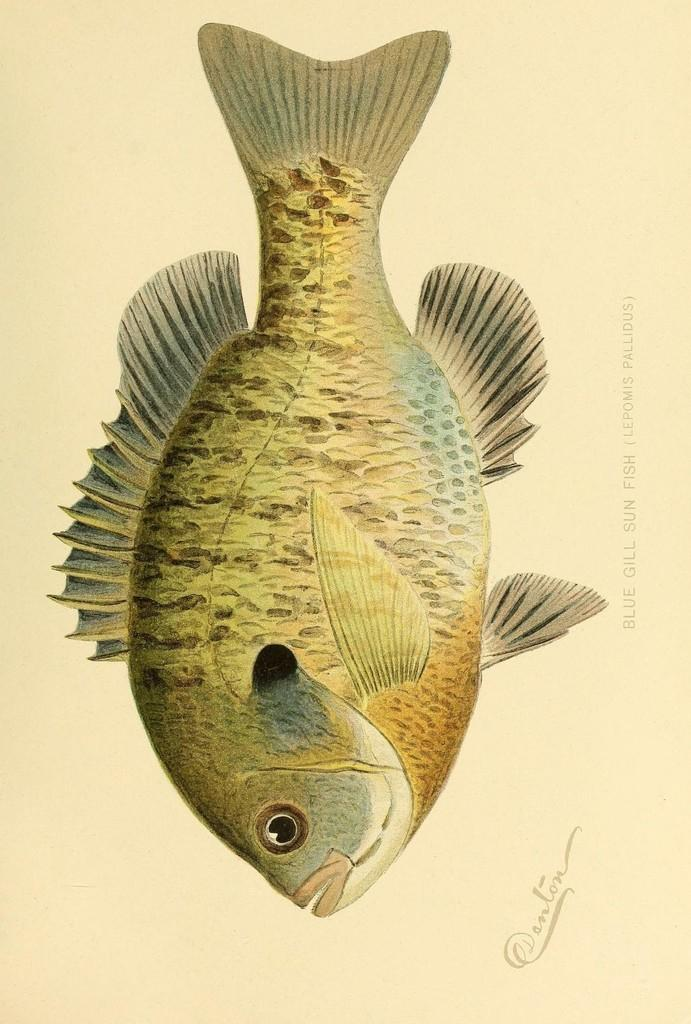What is the main subject of the painting in the image? The main subject of the painting in the image is a fish. What else can be seen on the right side of the image? There is text on the right side of the image. What color is the background of the image? The background of the image is cream-colored. What type of silk material is used to create the space-like environment in the image? There is no silk material or space-like environment present in the image; it features a painting of a fish with text on the right side and a cream-colored background. 